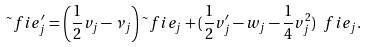<formula> <loc_0><loc_0><loc_500><loc_500>\tilde { \ } f i e _ { j } ^ { \prime } = \left ( \frac { 1 } { 2 } { v _ { j } } - \nu _ { j } \right ) \tilde { \ } f i e _ { j } + ( \frac { 1 } { 2 } { v _ { j } ^ { \prime } } - w _ { j } - \frac { 1 } { 4 } { v _ { j } ^ { 2 } } ) \ f i e _ { j } .</formula> 